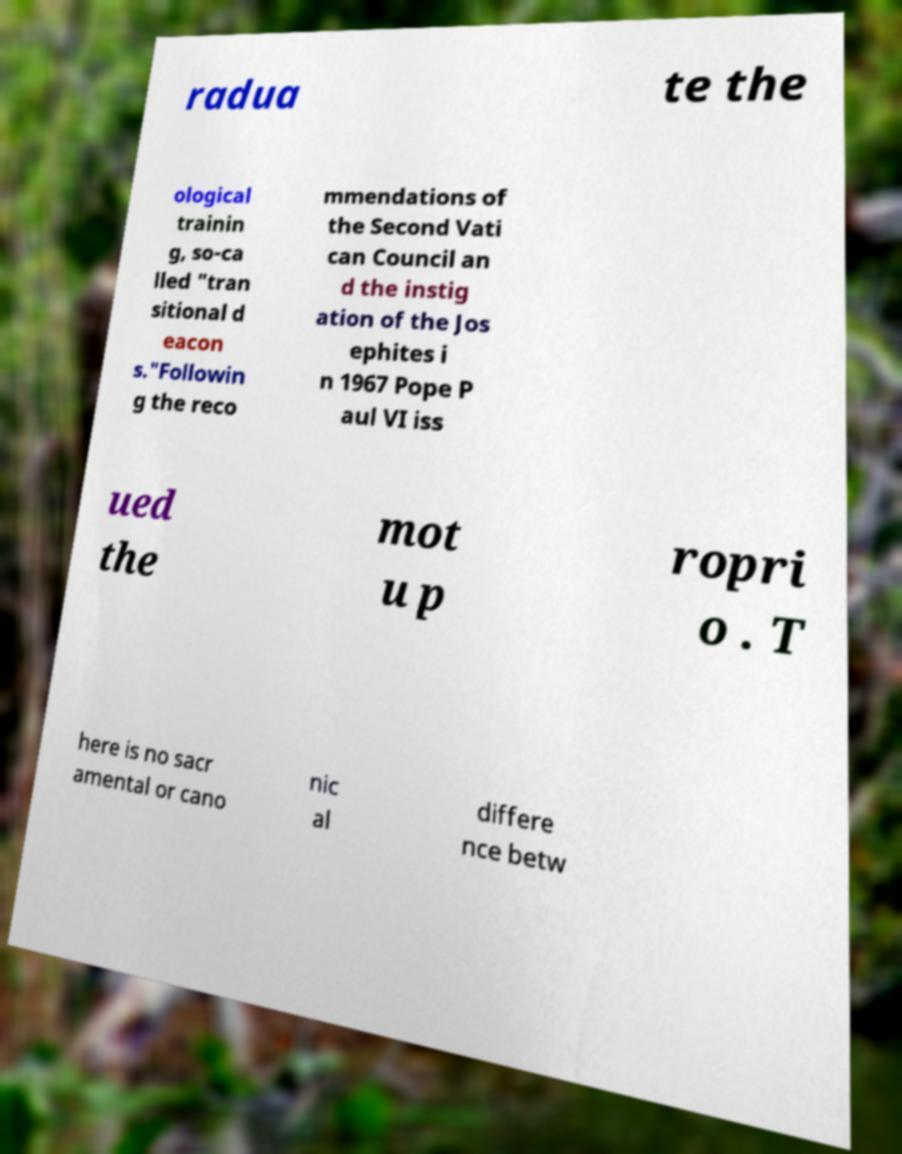Could you assist in decoding the text presented in this image and type it out clearly? radua te the ological trainin g, so-ca lled "tran sitional d eacon s."Followin g the reco mmendations of the Second Vati can Council an d the instig ation of the Jos ephites i n 1967 Pope P aul VI iss ued the mot u p ropri o . T here is no sacr amental or cano nic al differe nce betw 